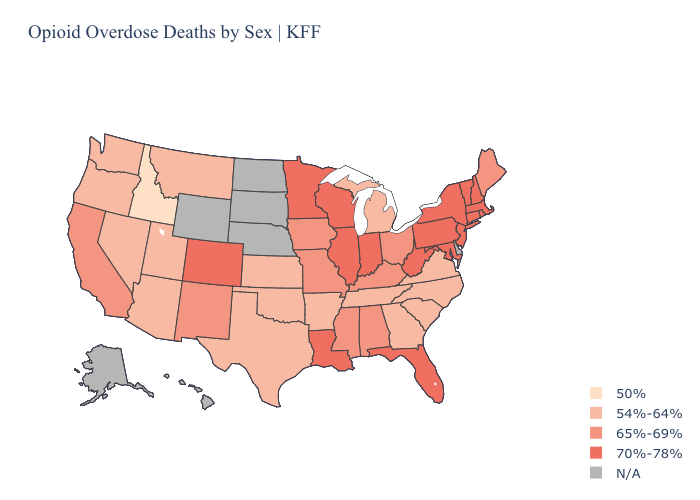What is the lowest value in states that border Georgia?
Concise answer only. 54%-64%. Which states have the highest value in the USA?
Quick response, please. Colorado, Connecticut, Florida, Illinois, Indiana, Louisiana, Maryland, Massachusetts, Minnesota, New Hampshire, New Jersey, New York, Pennsylvania, Rhode Island, Vermont, West Virginia, Wisconsin. Name the states that have a value in the range 54%-64%?
Concise answer only. Arizona, Arkansas, Georgia, Kansas, Michigan, Montana, Nevada, North Carolina, Oklahoma, Oregon, South Carolina, Tennessee, Texas, Utah, Virginia, Washington. Does Oregon have the lowest value in the USA?
Be succinct. No. What is the highest value in the USA?
Write a very short answer. 70%-78%. Does Alabama have the lowest value in the South?
Give a very brief answer. No. Which states have the lowest value in the West?
Keep it brief. Idaho. What is the value of Vermont?
Concise answer only. 70%-78%. Name the states that have a value in the range 70%-78%?
Keep it brief. Colorado, Connecticut, Florida, Illinois, Indiana, Louisiana, Maryland, Massachusetts, Minnesota, New Hampshire, New Jersey, New York, Pennsylvania, Rhode Island, Vermont, West Virginia, Wisconsin. Among the states that border Nebraska , does Kansas have the lowest value?
Give a very brief answer. Yes. Which states have the highest value in the USA?
Write a very short answer. Colorado, Connecticut, Florida, Illinois, Indiana, Louisiana, Maryland, Massachusetts, Minnesota, New Hampshire, New Jersey, New York, Pennsylvania, Rhode Island, Vermont, West Virginia, Wisconsin. Name the states that have a value in the range 70%-78%?
Concise answer only. Colorado, Connecticut, Florida, Illinois, Indiana, Louisiana, Maryland, Massachusetts, Minnesota, New Hampshire, New Jersey, New York, Pennsylvania, Rhode Island, Vermont, West Virginia, Wisconsin. Name the states that have a value in the range N/A?
Give a very brief answer. Alaska, Delaware, Hawaii, Nebraska, North Dakota, South Dakota, Wyoming. Which states have the lowest value in the West?
Be succinct. Idaho. 